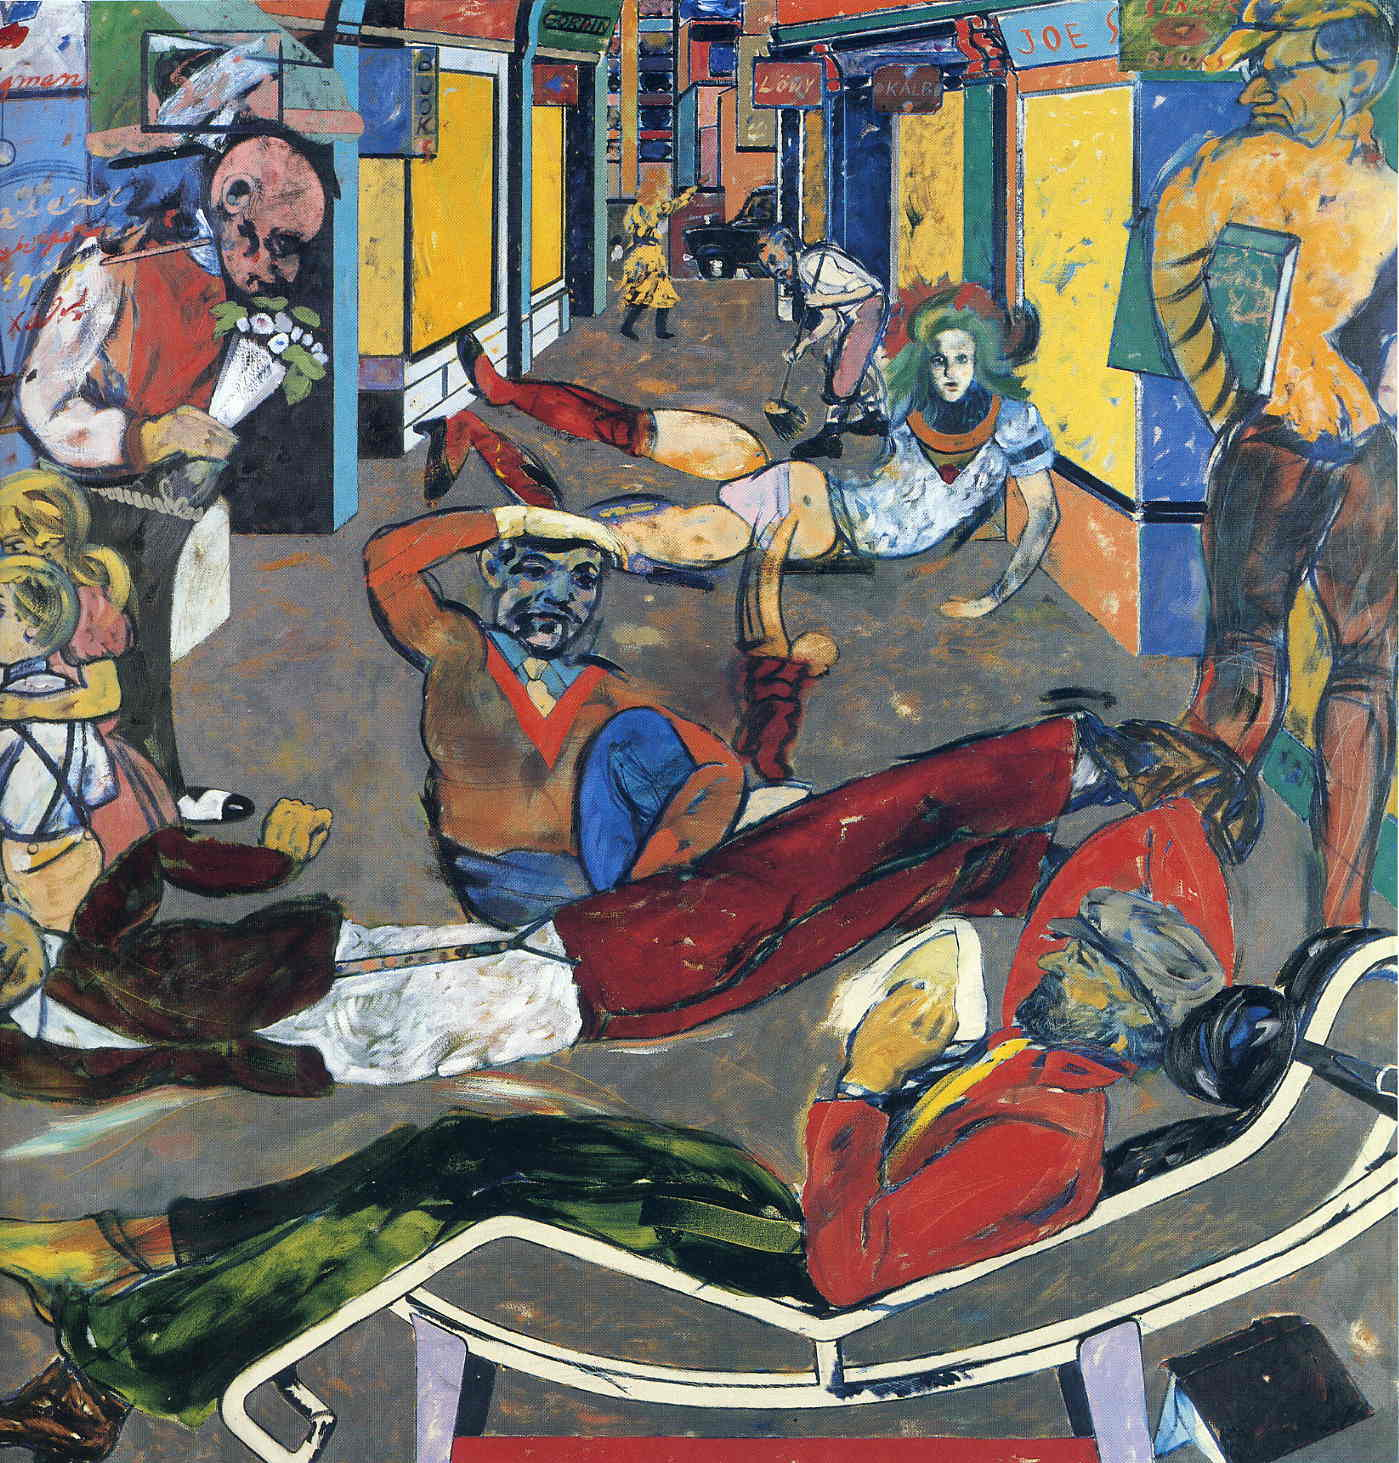Can you describe the mood of the artwork? The mood of the artwork is chaotic yet exuberant. The vibrant colors and dynamic postures of the figures convey a sense of energy and unrestrained movement. Despite the apparent disarray, there is an underlying sense of joy and celebration, as if the characters are caught in a fleeting moment of communal euphoria. Do you think the artist intended to convey a specific message with this painting? Given the expressionist style of the artwork, it is possible that the artist aimed to convey emotions and subjective experiences rather than a direct, concrete message. The use of distorted forms and vibrant colors suggests a focus on the inner emotional turmoil or exuberance of the characters. This could be interpreted as a commentary on the frenetic pace of modern urban life or the collective energy and spirit of the people within a community. What do you think inspired the artist to create such a scene? The artist may have been inspired by the dynamic and multifaceted nature of city life, capturing the essence of a bustling street and its diverse inhabitants. The exaggerated forms and intense colors reflect the sensory overload and emotional highs and lows experienced in an urban environment. Additionally, the artist might have been influenced by the post-impressionist movement, which often prioritized the expression of emotion and individual perspective over meticulous realism. 